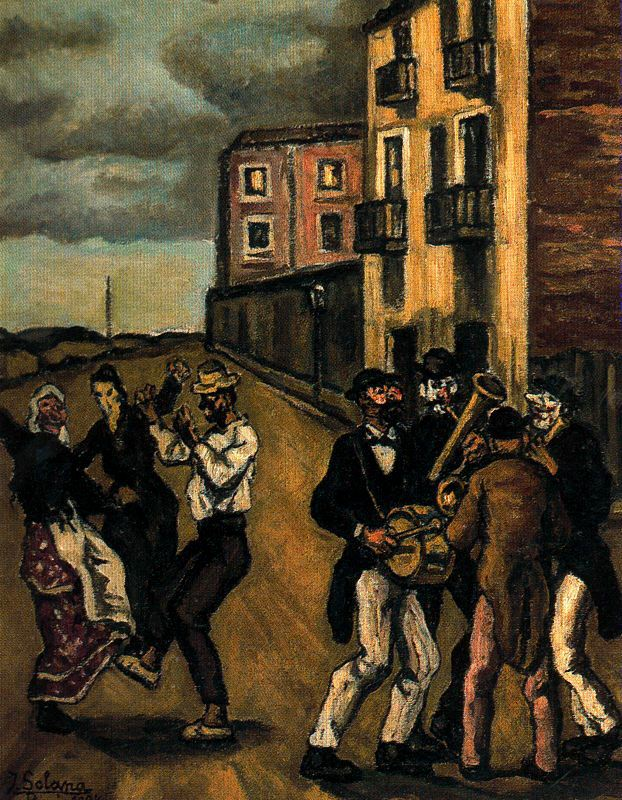If this artwork could tell a story, what do you think it would be about? This artwork could tell the story of a closely-knit community coming together to celebrate a special occasion, perhaps a local festival or a seasonal event. It portrays the beauty of unity and the joy found in shared traditions. Families and friends gather in the street, dancing and playing music, symbolizing harmony and the simple pleasures of life. The story might also highlight the resilience and spirit of the people, showing how they find solace and happiness in each other's company despite the struggles they face in their everyday lives. Expand on the possible historical context of this painting. What period do you think it represents, and what elements in the painting lead you to this conclusion? The painting likely represents a period in the late 19th to early 20th century, as suggested by the style of clothing and the architecture in the background. The men's attire, with items such as bowler hats and waistcoats, along with the women's dresses and shawls, reflect fashion trends of that era. The buildings, with their distinct, tall, and narrow facades, are characteristic of European architecture from this time. Moreover, the use of earthy tones and the focus on everyday life are hallmarks of post-impressionism and social realism, popular art movements during this period. These elements collectively suggest a historical context that emphasizes cultural traditions and communal experiences. Do you think there's a particular reason the artist chose these specific individuals and this setting for the painting? The artist might have chosen these specific individuals and this setting to emphasize the importance of community and cultural heritage. By depicting a lively street scene with people in traditional attire, the artist captures a sense of place and time that resonates with viewers. The setting likely represents a familiar locale to the artist, making the painting a personal and authentic reflection of their experiences and observations. The choice of individuals might be intentional to highlight the diversity and unity within the community, showcasing varied expressions of joy and engagement in the celebration. This selection creates a narrative that is universally relatable, celebrating human connection and the preservation of cultural traditions. If this painting were part of a larger series, what other scenes might be included? If this painting were part of a larger series, other scenes might include: 
1. **Preparation for the Festival:** A bustling marketplace where vendors sell vibrant textiles, fresh produce, and traditional foods in anticipation of the festival.
2. **A Quiet Moment:** Families at home, engaged in quiet activities such as cooking, sewing, or storytelling, highlighting daily life and customs.
3. **Children at Play:** Kids running through the streets, playing traditional games, and helping with the festival preparations, capturing the innocence and excitement of youth.
4. **Nightfall Over the Village:** The community coming together for an evening of song and dance, with lanterns illuminating the streets and the night sky adding a serene backdrop.
5. **Post-Celebration:** The following morning, showing the aftermath of the celebration with streets being cleaned, remnants of decorations, and people reminiscing about the joyous events.
Each scene would build on the themes of community, tradition, and the cyclical nature of everyday life, creating a rich tapestry of experiences that highlight the beauty of cultural continuity. 